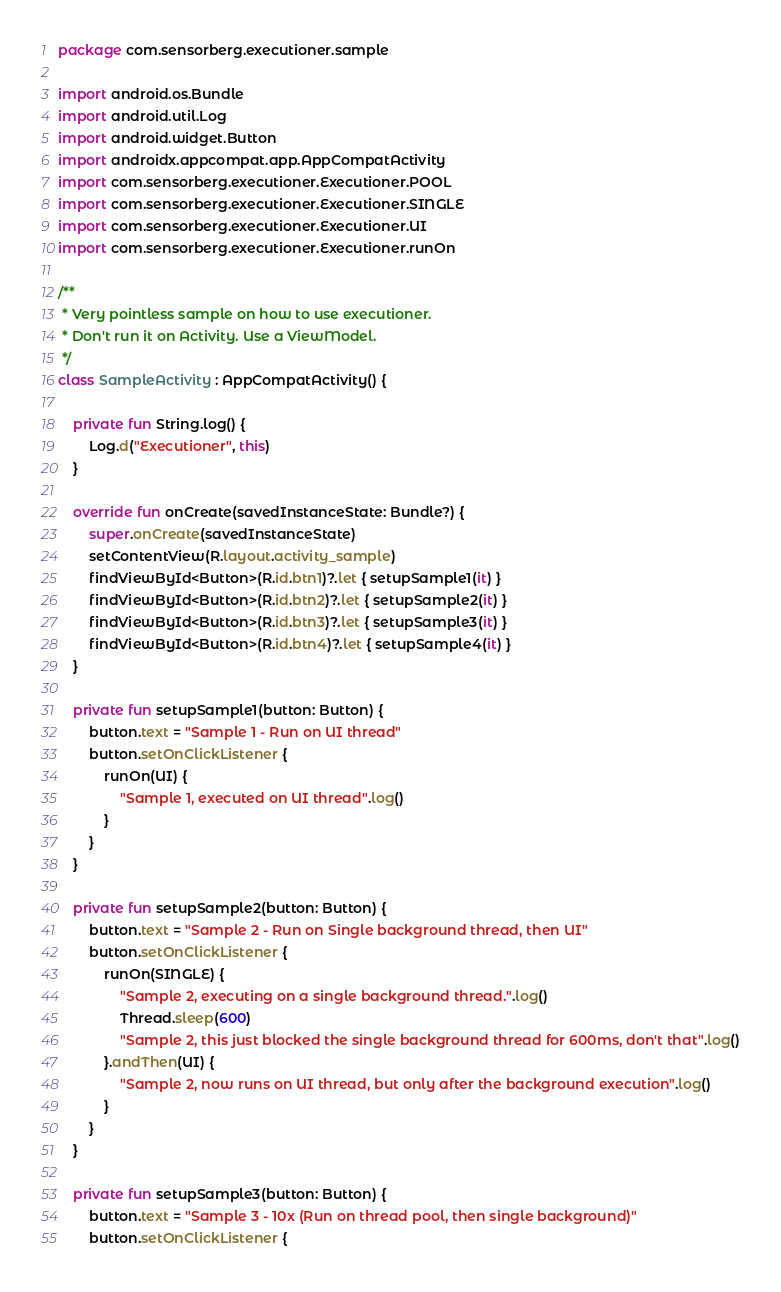<code> <loc_0><loc_0><loc_500><loc_500><_Kotlin_>package com.sensorberg.executioner.sample

import android.os.Bundle
import android.util.Log
import android.widget.Button
import androidx.appcompat.app.AppCompatActivity
import com.sensorberg.executioner.Executioner.POOL
import com.sensorberg.executioner.Executioner.SINGLE
import com.sensorberg.executioner.Executioner.UI
import com.sensorberg.executioner.Executioner.runOn

/**
 * Very pointless sample on how to use executioner.
 * Don't run it on Activity. Use a ViewModel.
 */
class SampleActivity : AppCompatActivity() {

    private fun String.log() {
        Log.d("Executioner", this)
    }

    override fun onCreate(savedInstanceState: Bundle?) {
        super.onCreate(savedInstanceState)
        setContentView(R.layout.activity_sample)
        findViewById<Button>(R.id.btn1)?.let { setupSample1(it) }
        findViewById<Button>(R.id.btn2)?.let { setupSample2(it) }
        findViewById<Button>(R.id.btn3)?.let { setupSample3(it) }
        findViewById<Button>(R.id.btn4)?.let { setupSample4(it) }
    }

    private fun setupSample1(button: Button) {
        button.text = "Sample 1 - Run on UI thread"
        button.setOnClickListener {
            runOn(UI) {
                "Sample 1, executed on UI thread".log()
            }
        }
    }

    private fun setupSample2(button: Button) {
        button.text = "Sample 2 - Run on Single background thread, then UI"
        button.setOnClickListener {
            runOn(SINGLE) {
                "Sample 2, executing on a single background thread.".log()
                Thread.sleep(600)
                "Sample 2, this just blocked the single background thread for 600ms, don't that".log()
            }.andThen(UI) {
                "Sample 2, now runs on UI thread, but only after the background execution".log()
            }
        }
    }

    private fun setupSample3(button: Button) {
        button.text = "Sample 3 - 10x (Run on thread pool, then single background)"
        button.setOnClickListener {</code> 